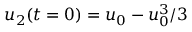<formula> <loc_0><loc_0><loc_500><loc_500>u _ { 2 } ( t = 0 ) = u _ { 0 } - u _ { 0 } ^ { 3 } / 3</formula> 